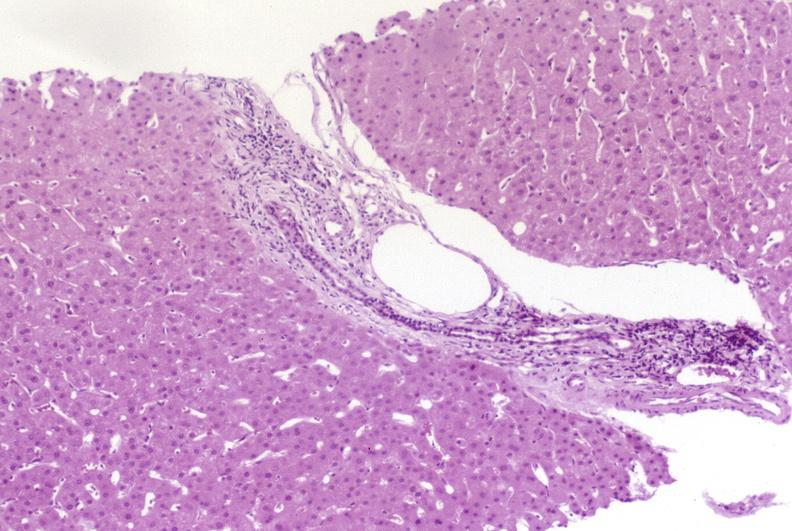s hepatobiliary present?
Answer the question using a single word or phrase. Yes 